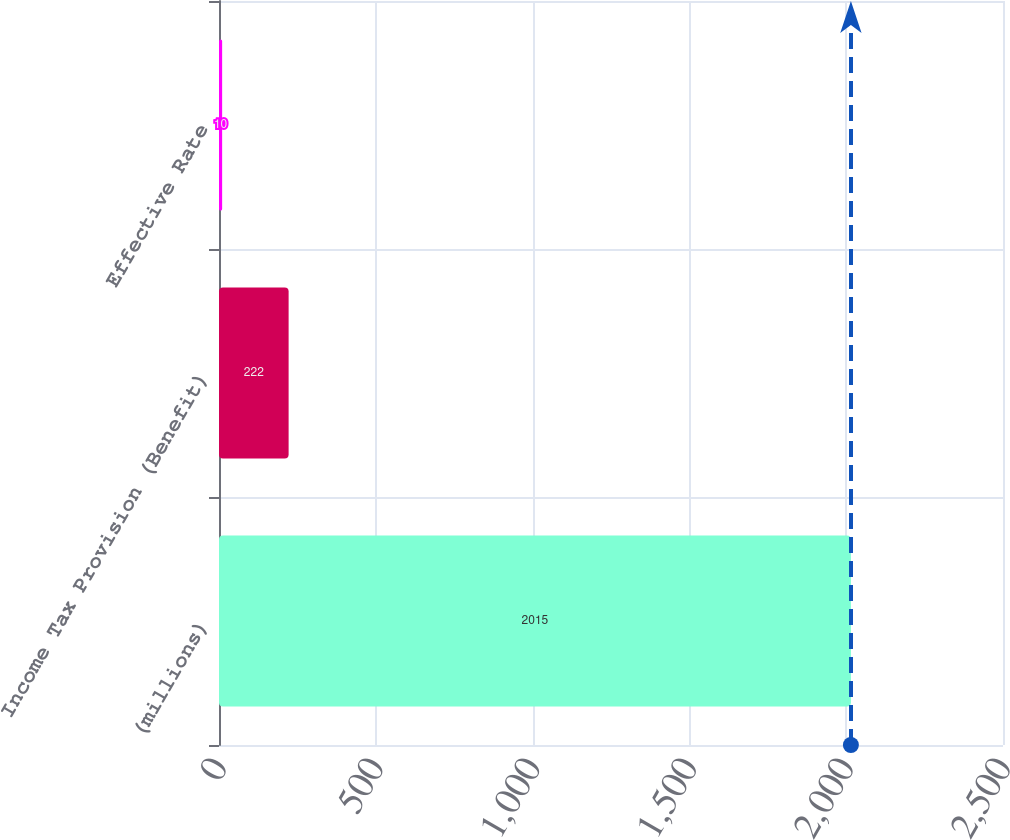Convert chart. <chart><loc_0><loc_0><loc_500><loc_500><bar_chart><fcel>(millions)<fcel>Income Tax Provision (Benefit)<fcel>Effective Rate<nl><fcel>2015<fcel>222<fcel>10<nl></chart> 